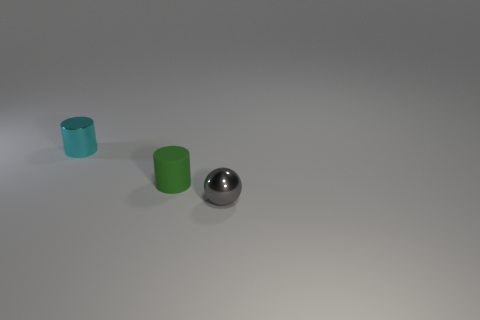Add 3 tiny gray metal objects. How many objects exist? 6 Subtract all balls. How many objects are left? 2 Subtract 0 purple cylinders. How many objects are left? 3 Subtract all brown balls. Subtract all blue blocks. How many balls are left? 1 Subtract all big cyan objects. Subtract all tiny metallic spheres. How many objects are left? 2 Add 3 tiny balls. How many tiny balls are left? 4 Add 1 small green cylinders. How many small green cylinders exist? 2 